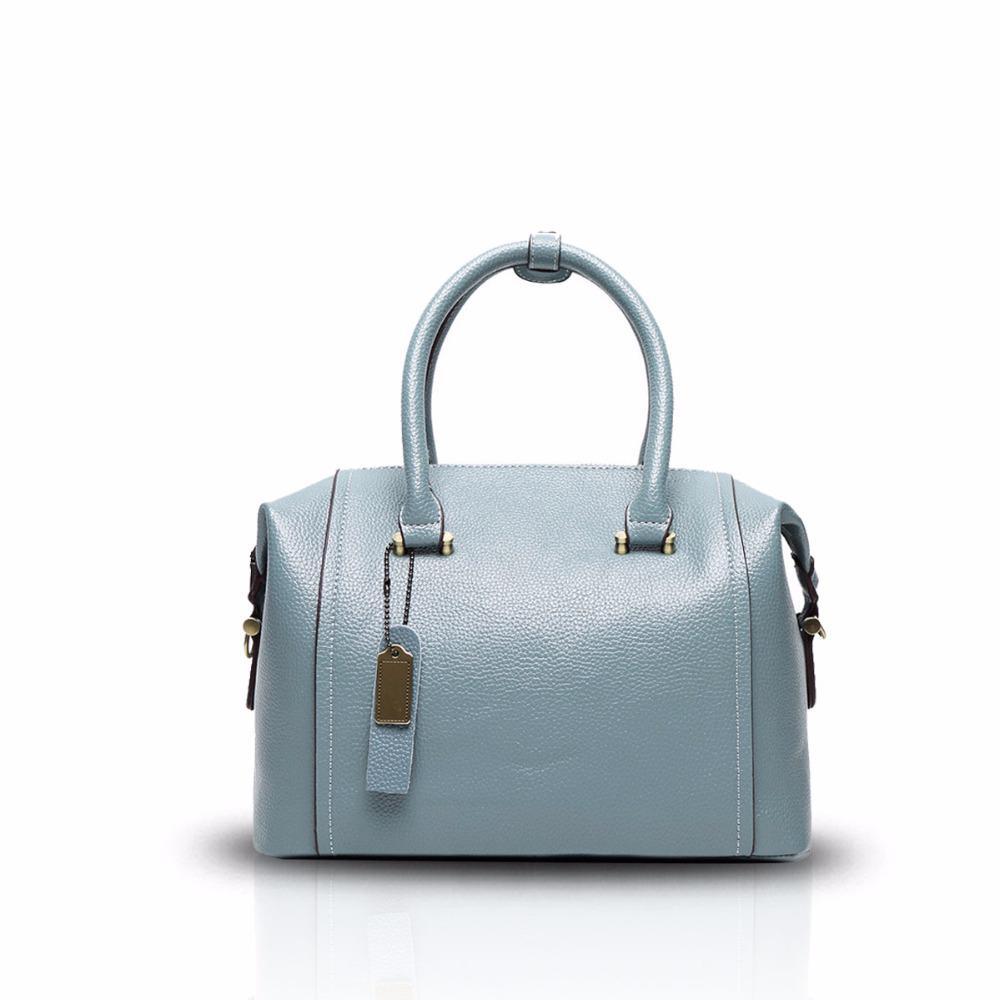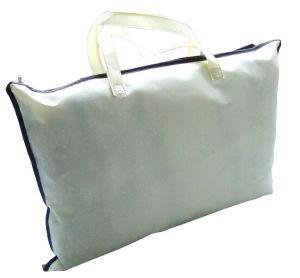The first image is the image on the left, the second image is the image on the right. Examine the images to the left and right. Is the description "The bags in the left and right images are displayed in the same position." accurate? Answer yes or no. No. The first image is the image on the left, the second image is the image on the right. Examine the images to the left and right. Is the description "The purse in the left image is predominately blue." accurate? Answer yes or no. Yes. 